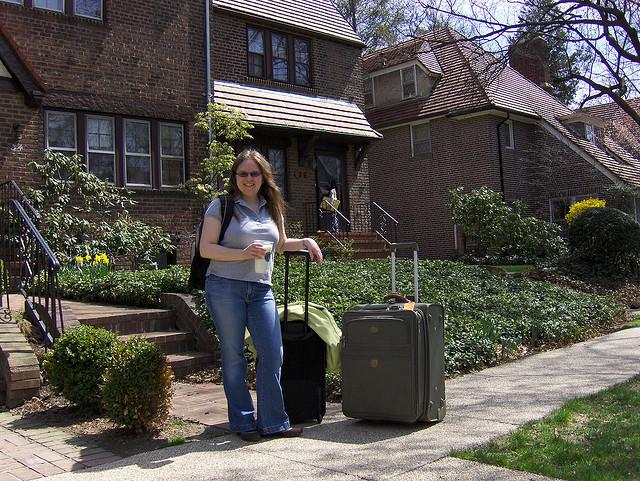What food and beverage purveyor did this woman visit most recently? Please explain your reasoning. starbucks. The woman has a starbucks logo on her cup. 